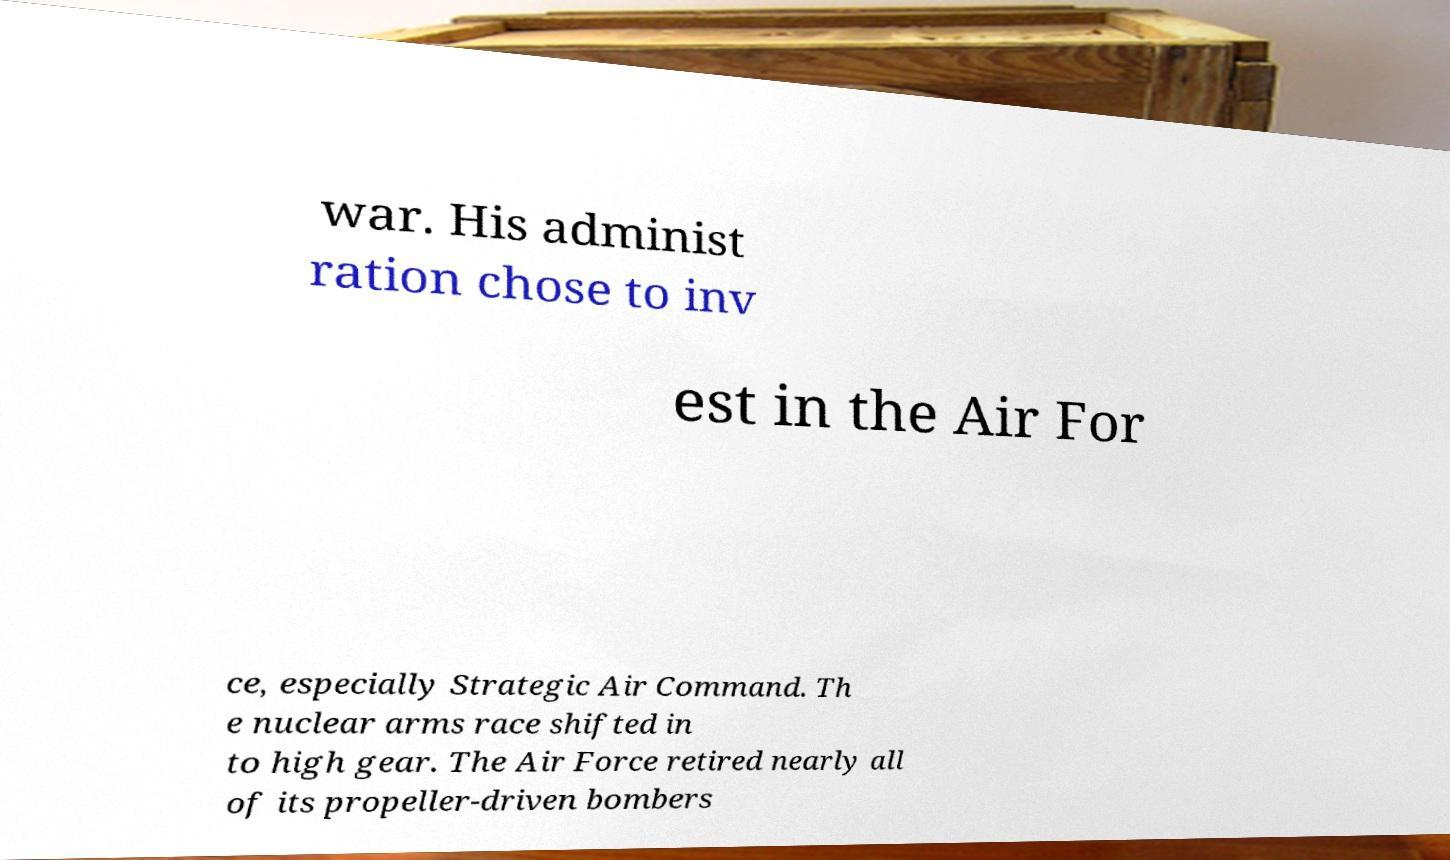Can you read and provide the text displayed in the image?This photo seems to have some interesting text. Can you extract and type it out for me? war. His administ ration chose to inv est in the Air For ce, especially Strategic Air Command. Th e nuclear arms race shifted in to high gear. The Air Force retired nearly all of its propeller-driven bombers 